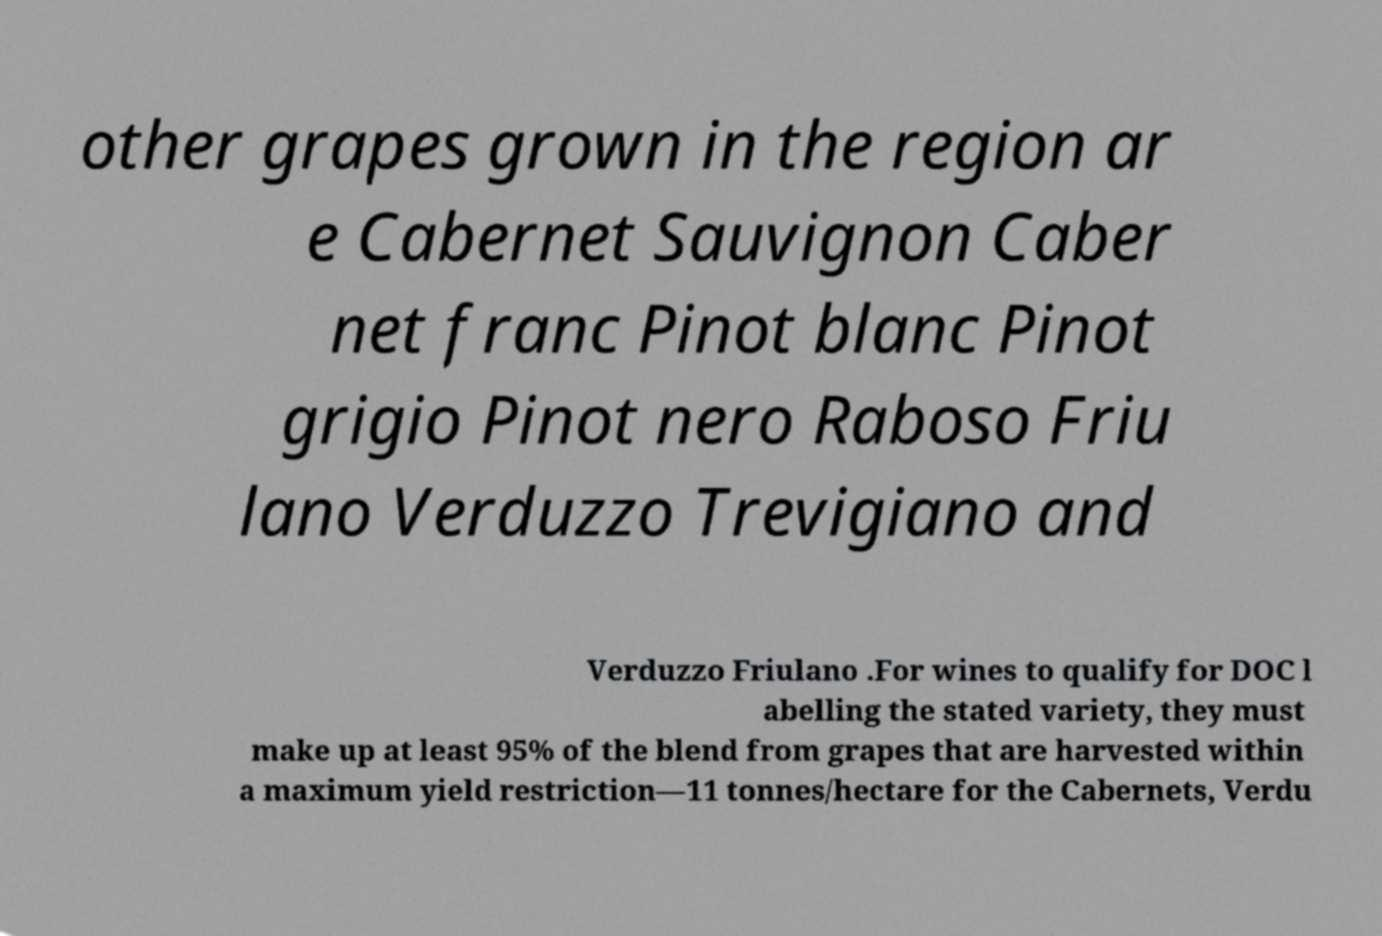Could you assist in decoding the text presented in this image and type it out clearly? other grapes grown in the region ar e Cabernet Sauvignon Caber net franc Pinot blanc Pinot grigio Pinot nero Raboso Friu lano Verduzzo Trevigiano and Verduzzo Friulano .For wines to qualify for DOC l abelling the stated variety, they must make up at least 95% of the blend from grapes that are harvested within a maximum yield restriction—11 tonnes/hectare for the Cabernets, Verdu 